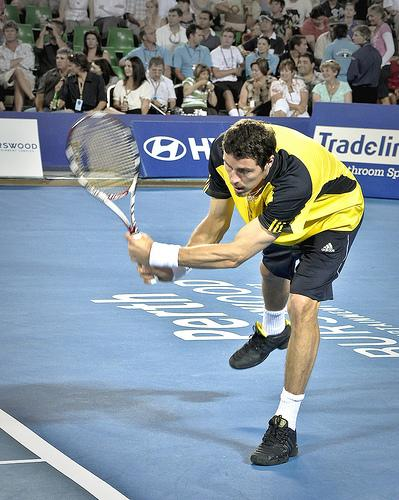Please give an overview of the image based on the object image data. The image features a male tennis player wearing a yellow and black shirt and black shorts on a blue tennis court, swinging his racket, while spectators watch. Please provide a brief description of the spectators watching the tennis game, as per the image data. The spectators seem to be looking towards the left side, likely following the trajectory of the tennis ball. What are the two types of footwear mentioned in the image, and in what context are they mentioned? The bounding boxes mention black athletic sneakers and black tennis shoes, worn by the tennis player. What is a unique feature of the man's arm, according to the image? The man is wearing white arm bands or sweatbands on his wrists. Summarize the overall sentiment of the image based on the image' information. The image seems to have an energetic and engaging atmosphere, depicting a riveting tennis match with an active player and attentive audience. Describe the position of the tennis player and what he is doing, based on the image. The tennis player is leaning forward while swinging his racket, likely hitting a ball during a tennis game. What is the surface color and markings on the tennis court according to the image? The tennis court is blue, and it has white print or lettering on it. Mention two specific items of the tennis player’s outfit, apart from their shirt, indicated by the image. The tennis player is wearing black shorts with an Adidas sign and white sweatbands around their wrists. Based on the image, identify the color and design of the tennis player's shirt. The tennis player has a yellow shirt with black lines, possibly in a striped pattern. Based on the image data, describe a person's view at an event in the image. The person might be viewing a tennis game where the male tennis player is swinging his racket, and other spectators are gazing to the left in anticipation. Mention any brand logo present on the tennis player's clothing or accessories. Adidas logo on shorts Determine if there's anything unexpectedly visible in the image. No unexpected elements found, all relevant to the tennis match. What is the overall sentiment conveyed by the image? Active and competitive atmosphere. What are the colors of the tennis player’s clothes? Yellow and black shirt, black shorts Describe the main activity shown in the image.  A man is playing tennis. Which of the following is described by "mans shorts are black": (a) shirt (b) the banner (c) a wristband (d) shorts? (d) shorts Is the tennis player wearing a green shirt? The correct information states that the man is wearing a yellow and black shirt, not green. How do the spectators appear to be reacting to the tennis game? They're looking to the left, possibly engaged with the game. Identify the sports activity depicted in the picture. Tennis Identify any unusual or unexpected element in the image related to a tennis match. No anomaly detected, everything appears to be relevant to a tennis match. Does the woman in the stands have black hair? There is no information about the hair color of the woman in the stands, so it cannot be confirmed or denied whether she has black hair. Which entity is described as "the man wearing a white sweatband"? The tennis player. Is the Adidas logo on the man's shirt? The Adidas logo is mentioned to be on the man's shorts, not on the shirt. Identify any text or brand logos visible in the image. Adidas logo on shorts and white lettering on the court. Does the man wear a purple sweatband on his wrist? The man is wearing a white sweatband, not purple. What's the overall mood portrayed in the image? Active and competitive Which object is referenced by "shadow on the tennis court"? The shadow on the ground, possibly caused by the man Is the tennis player wearing matching tennis shoes? Yes, both shoes are black Is the tennis court green with white lines? The court is specified as blue with white lines, not green. List the main objects found in the image. tennis player, racket, tennis court, spectators, tennis shoes, white socks, wristband, jersey, shorts, promotional advertisement Analyze and describe how the tennis player interacts with other objects in the scene. The tennis player swings his racket at the ball, wears a wristband, shoes and clothes, and plays on the tennis court while spectators watch. Is the man wearing red tennis shoes? The information mentions black tennis shoes, not red. Describe the color and fabric of the man's shirt and shorts. Yellow and black, possibly in polyester or similar sports fabric. Evaluate the quality of the image by mentioning its clarity, brightness, and sharpness. The image is clear, with good brightness and sharp details. 